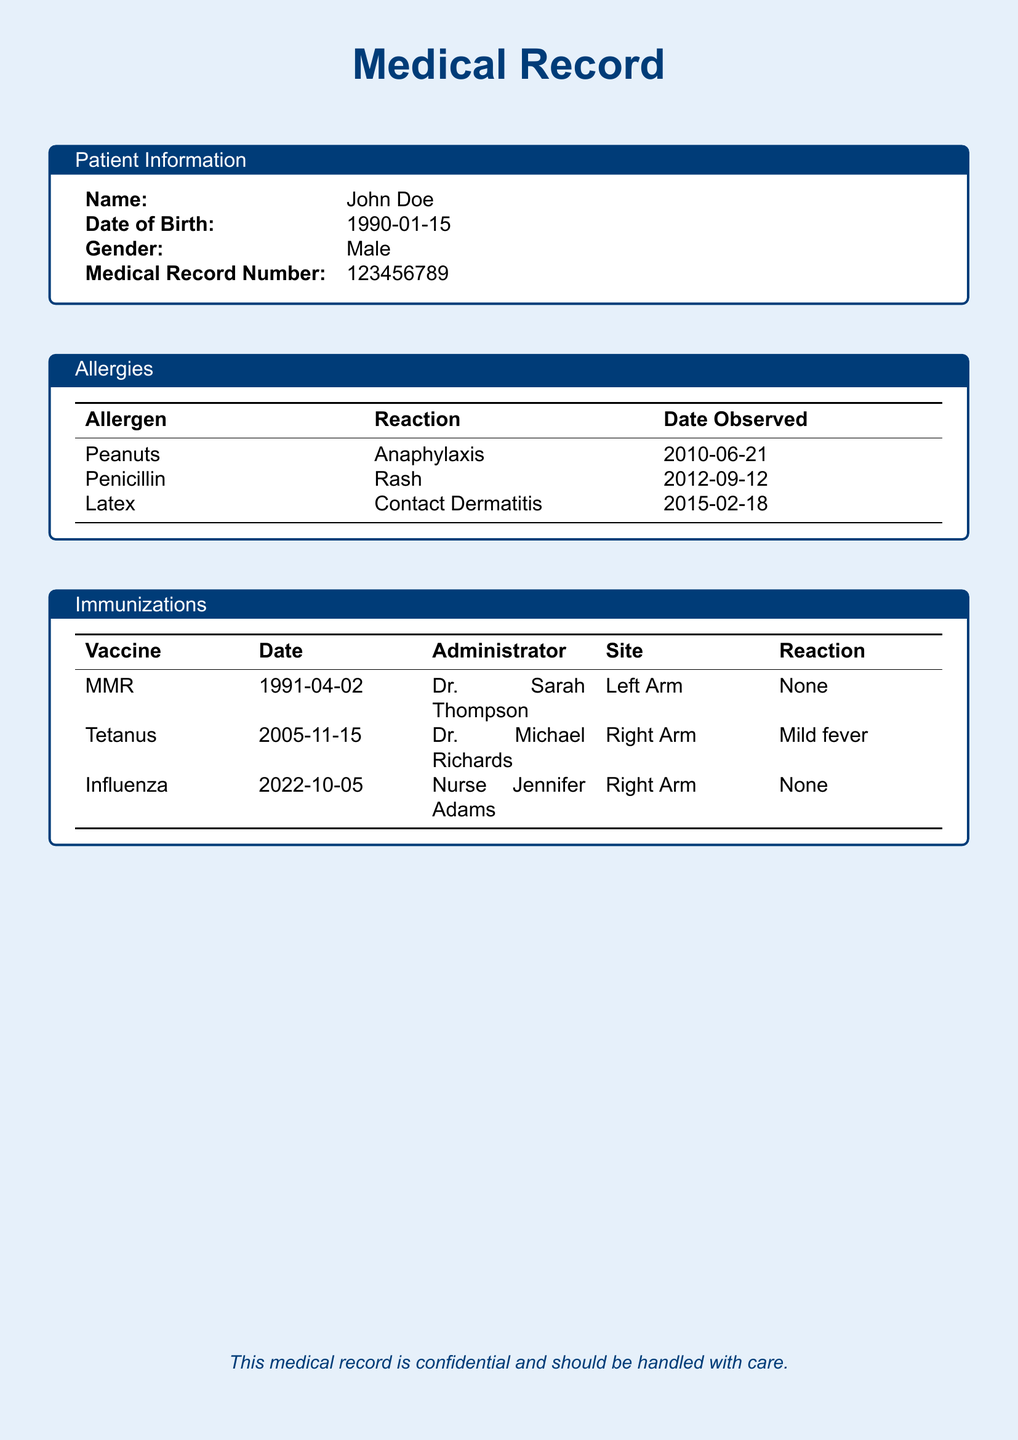What is the name of the patient? The patient's name is listed in the Patient Information section.
Answer: John Doe What is the date of birth of the patient? The date of birth can be found in the Patient Information box.
Answer: 1990-01-15 What was the reaction to peanuts? The reaction to peanuts is detailed in the Allergies section.
Answer: Anaphylaxis When was the Tetanus vaccine administered? The administration date of the Tetanus vaccine is found in the Immunizations table.
Answer: 2005-11-15 Who administered the MMR vaccine? The name of the administrator for the MMR vaccine is included in the Immunizations section.
Answer: Dr. Sarah Thompson What was the reaction to the Influenza vaccine? The Immunizations section provides information on the reaction to the Influenza vaccine.
Answer: None How many allergies are listed? The number of allergies can be determined by counting the entries in the Allergies table.
Answer: 3 What vaccine was administered on 2022-10-05? The vaccine administered on this date can be found in the Immunizations section.
Answer: Influenza What type of document is this? The title at the top of the document indicates the type of document.
Answer: Medical Record 